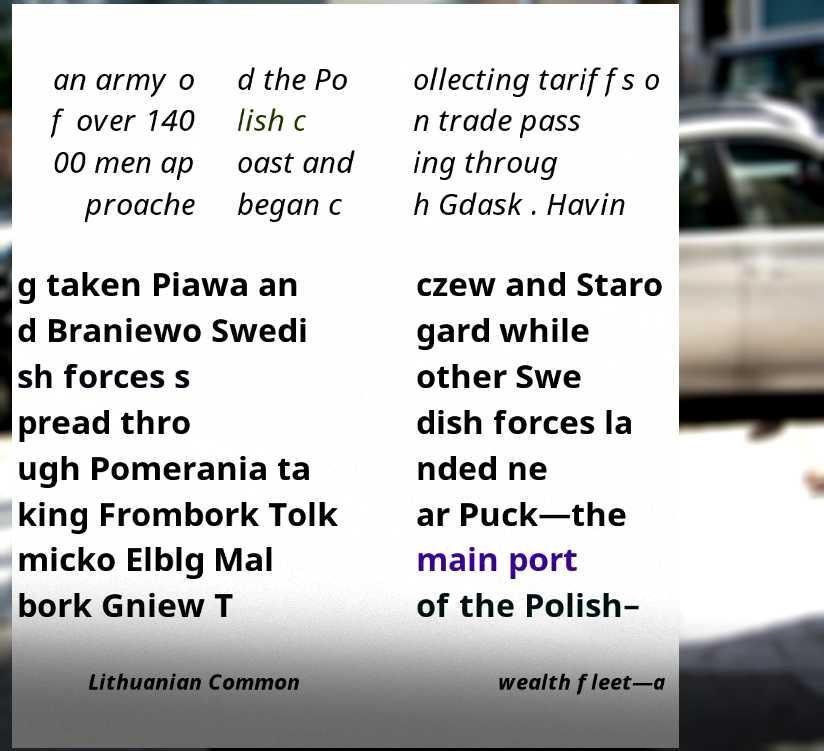For documentation purposes, I need the text within this image transcribed. Could you provide that? an army o f over 140 00 men ap proache d the Po lish c oast and began c ollecting tariffs o n trade pass ing throug h Gdask . Havin g taken Piawa an d Braniewo Swedi sh forces s pread thro ugh Pomerania ta king Frombork Tolk micko Elblg Mal bork Gniew T czew and Staro gard while other Swe dish forces la nded ne ar Puck—the main port of the Polish– Lithuanian Common wealth fleet—a 